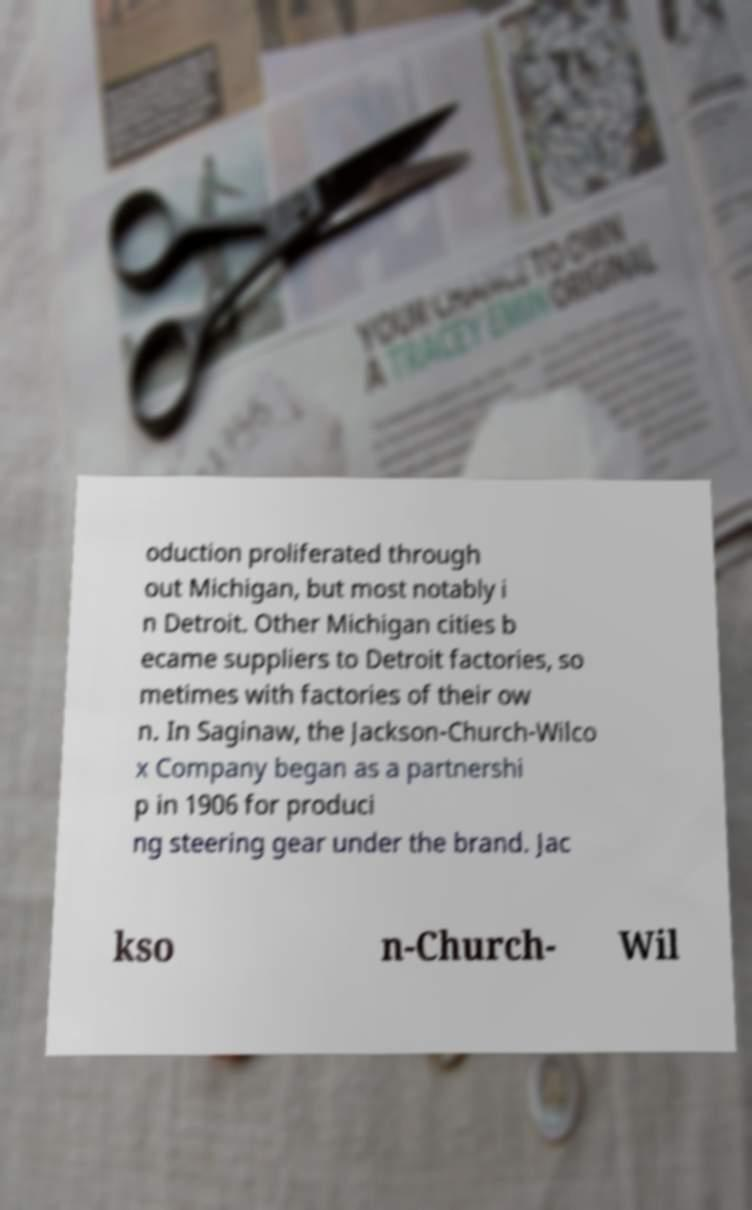Could you assist in decoding the text presented in this image and type it out clearly? oduction proliferated through out Michigan, but most notably i n Detroit. Other Michigan cities b ecame suppliers to Detroit factories, so metimes with factories of their ow n. In Saginaw, the Jackson-Church-Wilco x Company began as a partnershi p in 1906 for produci ng steering gear under the brand. Jac kso n-Church- Wil 